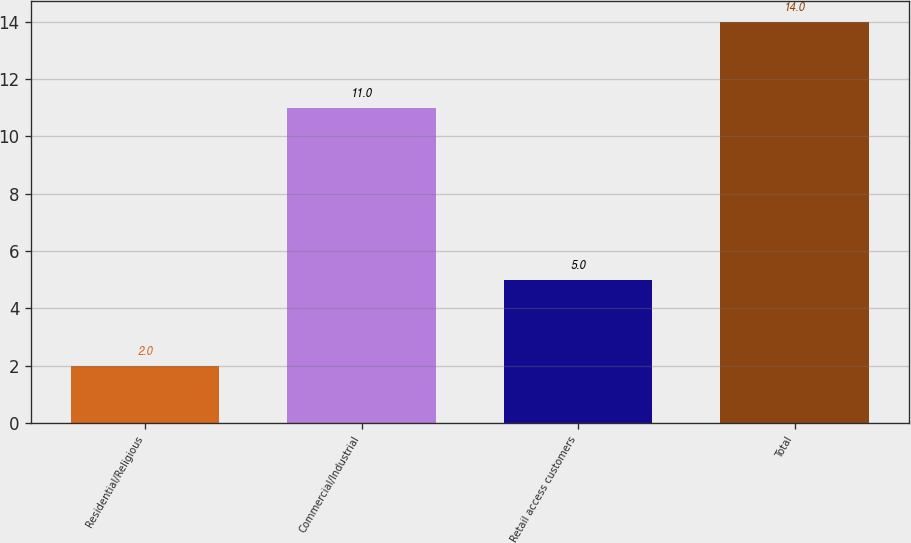Convert chart to OTSL. <chart><loc_0><loc_0><loc_500><loc_500><bar_chart><fcel>Residential/Religious<fcel>Commercial/Industrial<fcel>Retail access customers<fcel>Total<nl><fcel>2<fcel>11<fcel>5<fcel>14<nl></chart> 